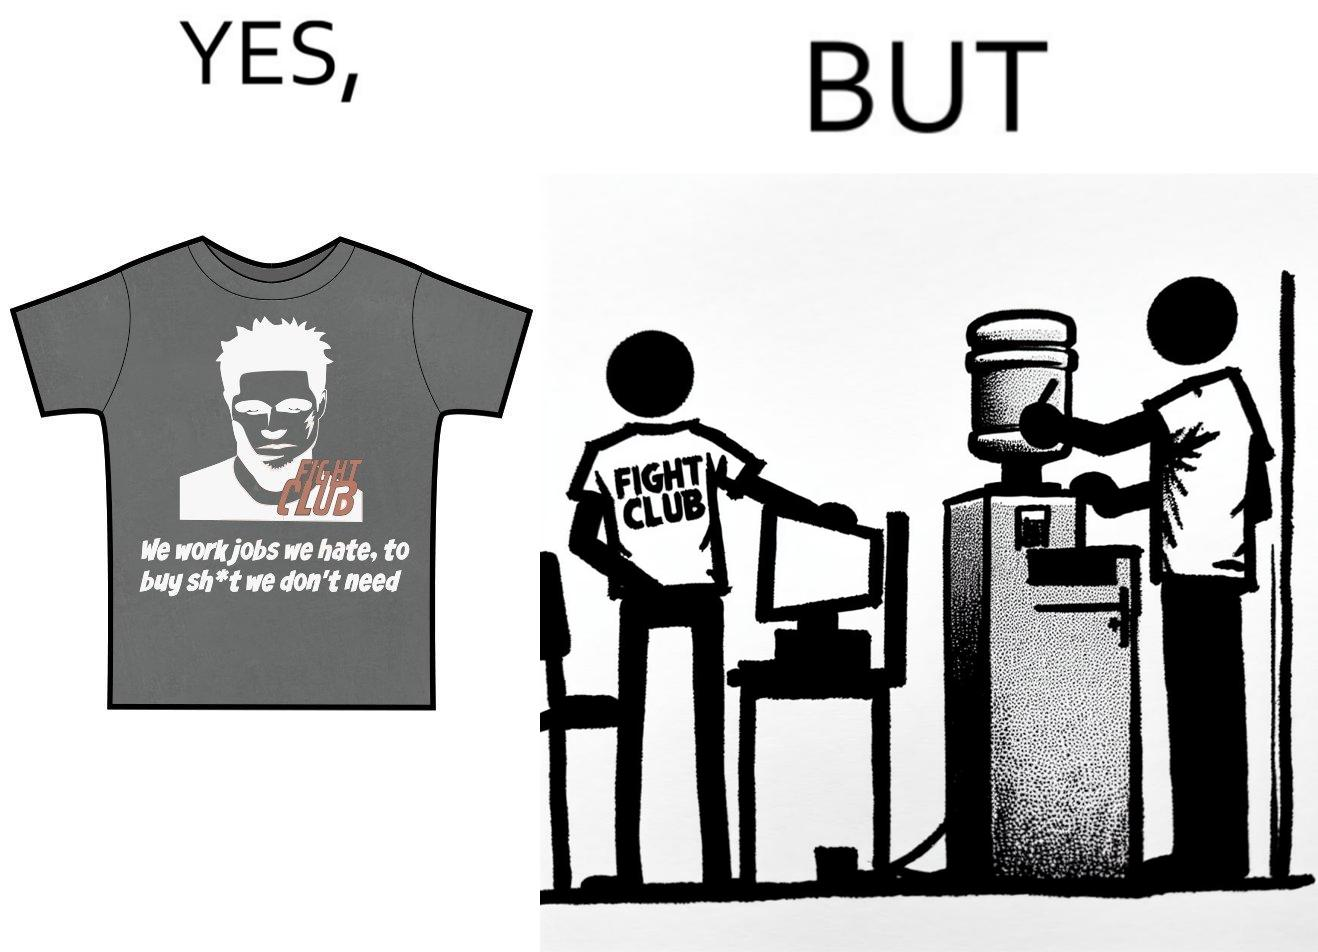What does this image depict? The image is ironical, as the t-shirt says "We work jobs we hate, to buy sh*t we don't need", which is a rebellious message against the construct of office jobs. However, the person wearing the t-shirt seems to be working in an office environment. Also, the t-shirt might have been bought using the money earned via the very same job. 